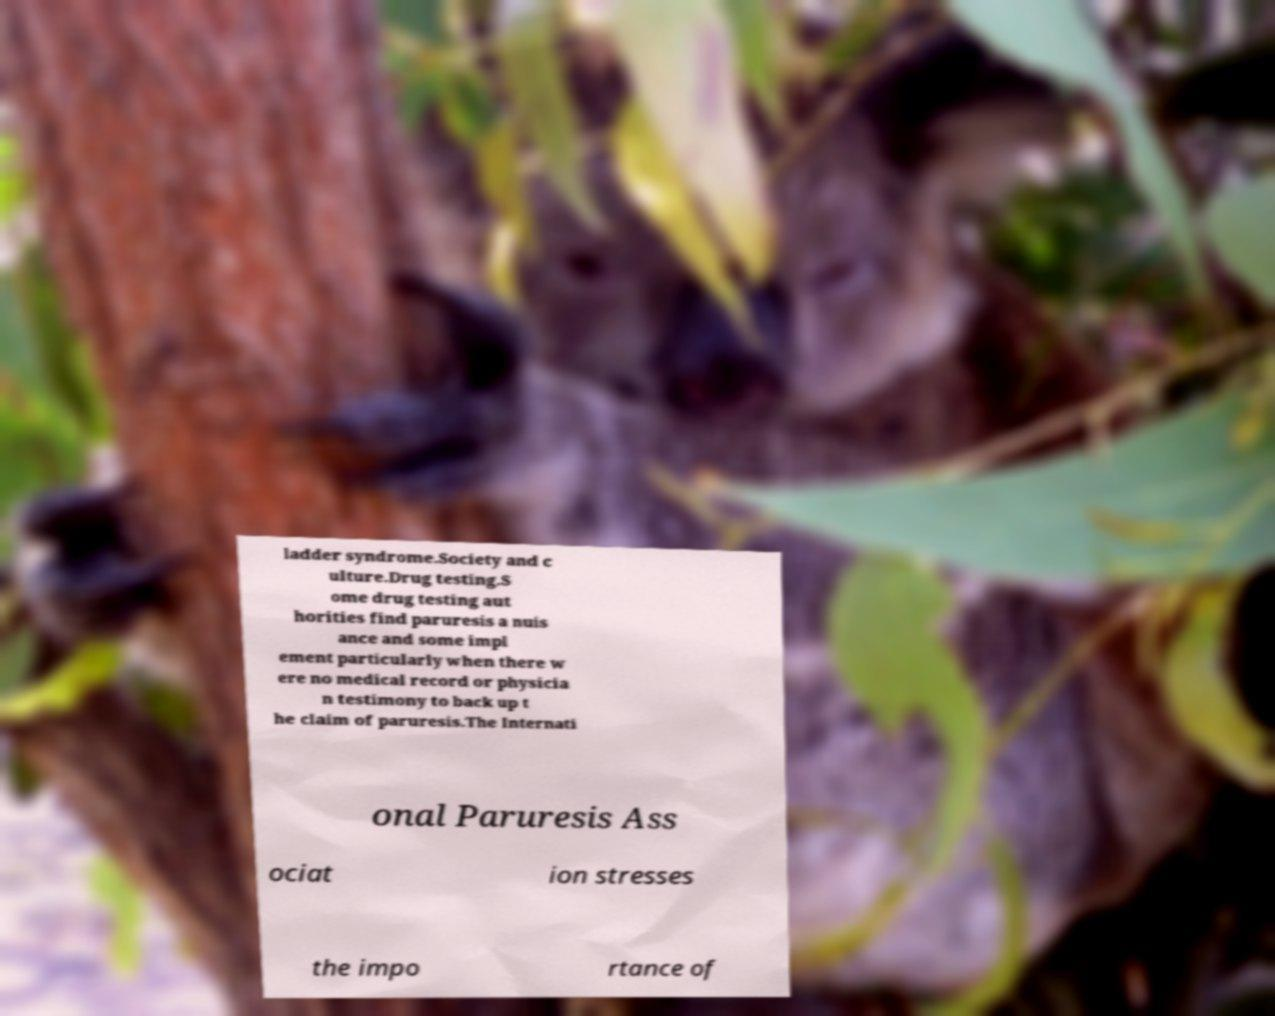Could you assist in decoding the text presented in this image and type it out clearly? ladder syndrome.Society and c ulture.Drug testing.S ome drug testing aut horities find paruresis a nuis ance and some impl ement particularly when there w ere no medical record or physicia n testimony to back up t he claim of paruresis.The Internati onal Paruresis Ass ociat ion stresses the impo rtance of 